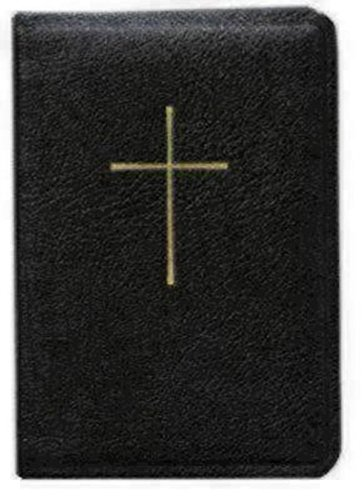What is the genre of this book? This book belongs to the genre of 'Christian Books & Bibles', which suggests it likely contains religious texts central to Christian worship, such as prayers, liturgies, and possibly hymns. 